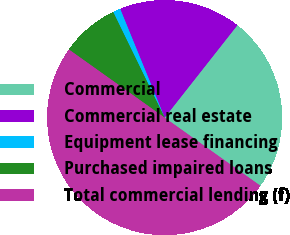Convert chart to OTSL. <chart><loc_0><loc_0><loc_500><loc_500><pie_chart><fcel>Commercial<fcel>Commercial real estate<fcel>Equipment lease financing<fcel>Purchased impaired loans<fcel>Total commercial lending (f)<nl><fcel>24.23%<fcel>16.79%<fcel>1.04%<fcel>7.94%<fcel>50.0%<nl></chart> 